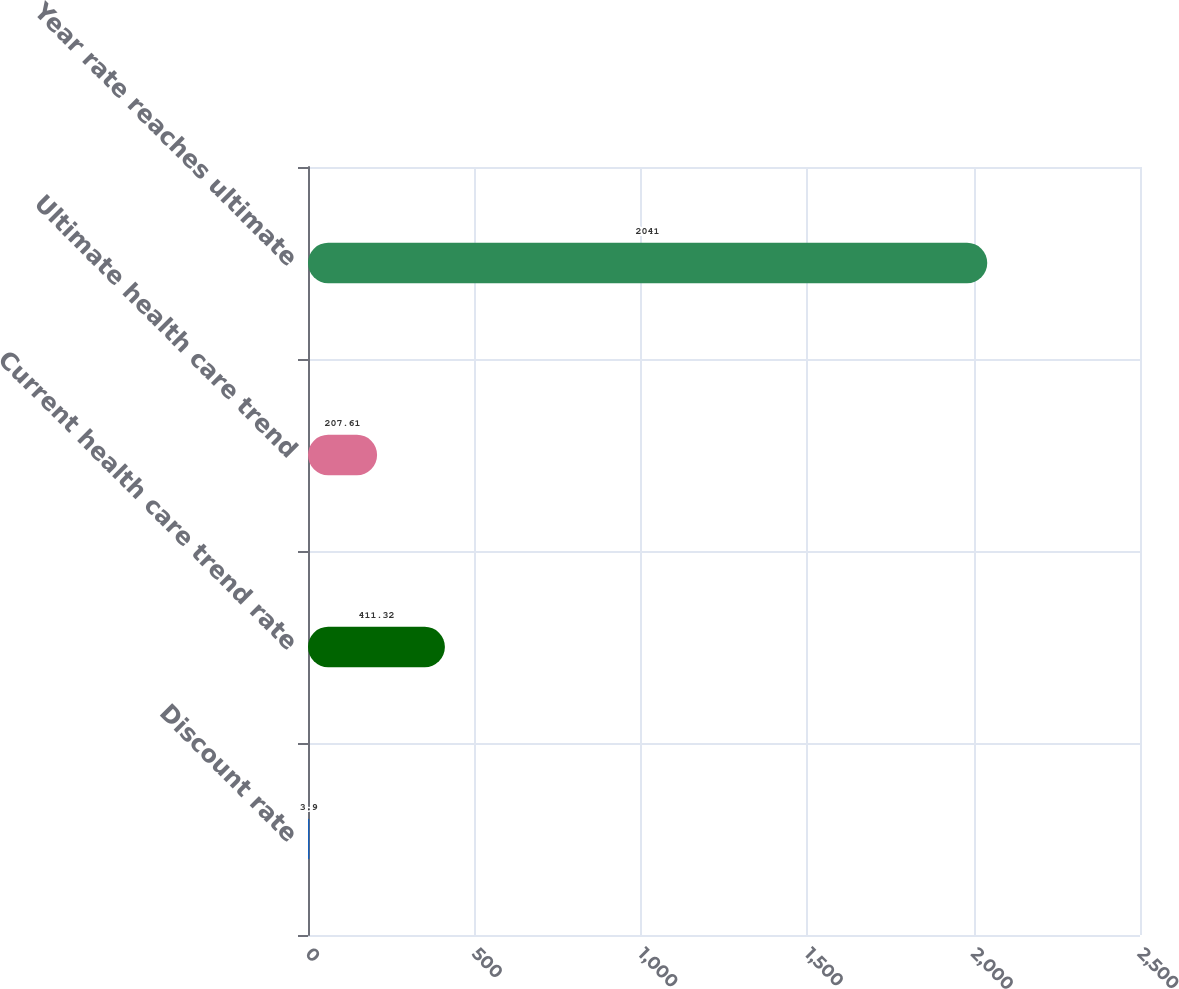Convert chart to OTSL. <chart><loc_0><loc_0><loc_500><loc_500><bar_chart><fcel>Discount rate<fcel>Current health care trend rate<fcel>Ultimate health care trend<fcel>Year rate reaches ultimate<nl><fcel>3.9<fcel>411.32<fcel>207.61<fcel>2041<nl></chart> 